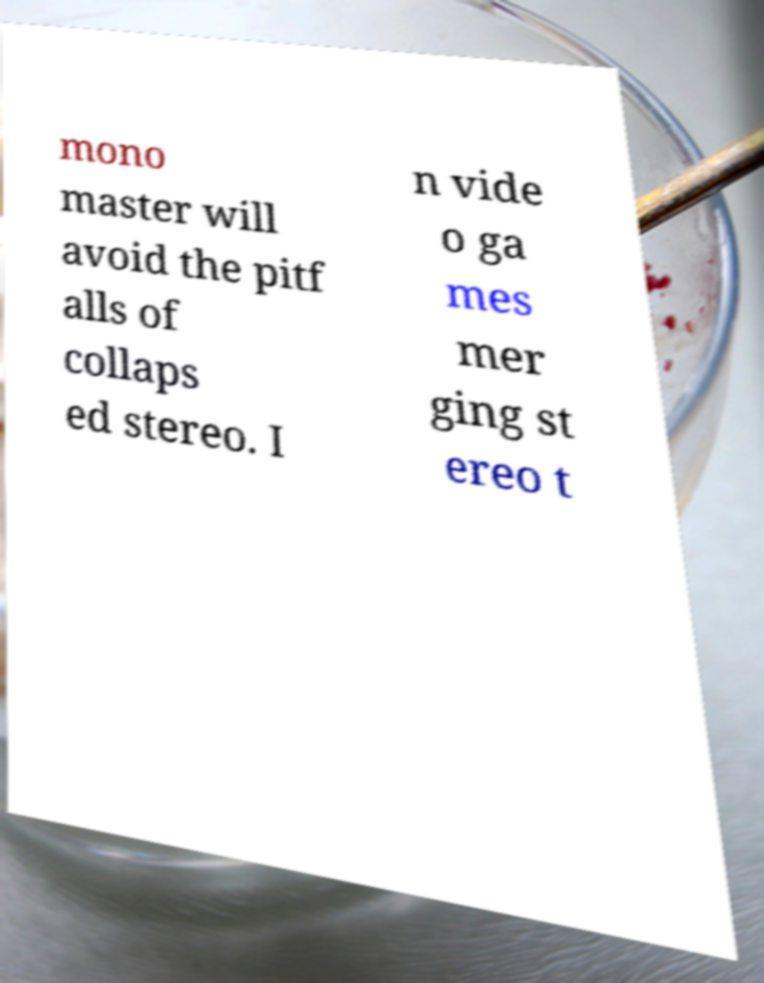What messages or text are displayed in this image? I need them in a readable, typed format. mono master will avoid the pitf alls of collaps ed stereo. I n vide o ga mes mer ging st ereo t 